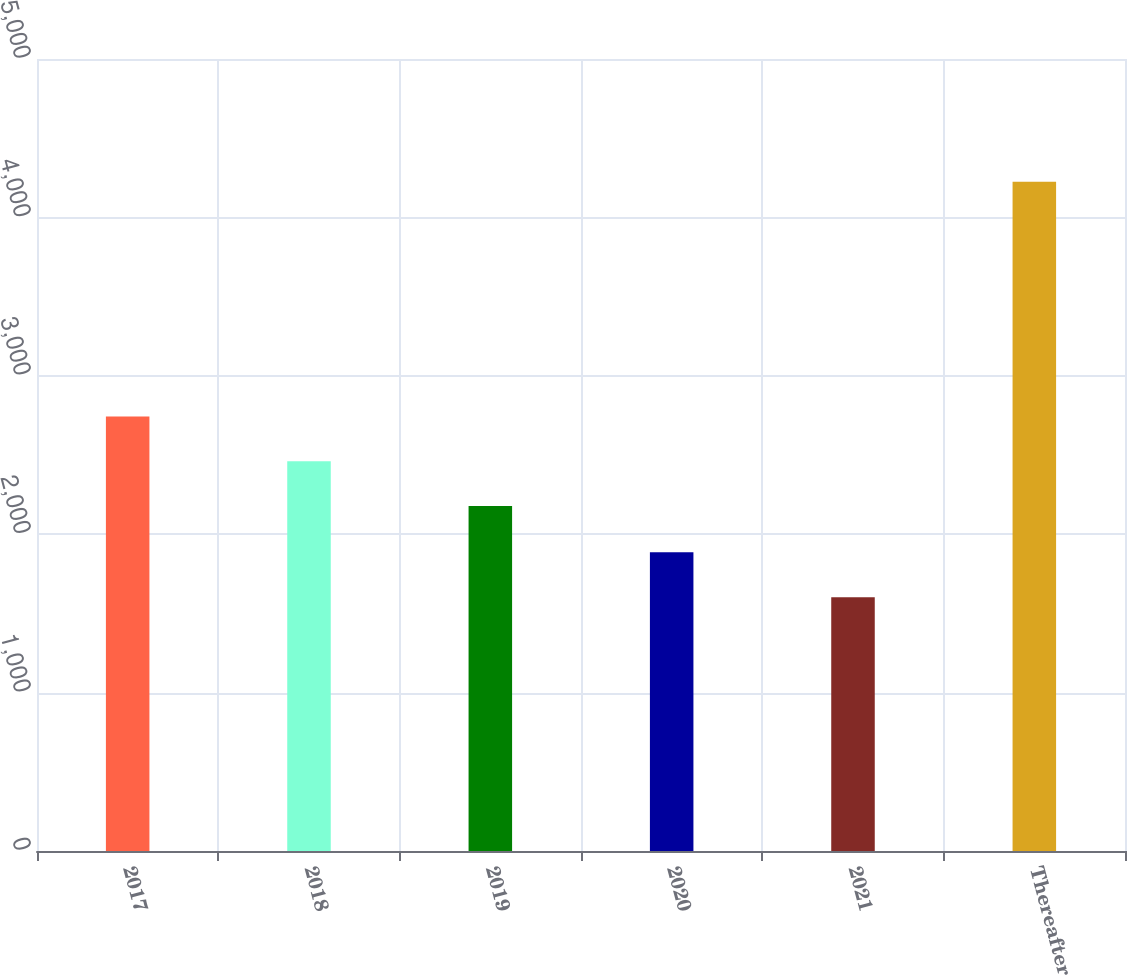Convert chart to OTSL. <chart><loc_0><loc_0><loc_500><loc_500><bar_chart><fcel>2017<fcel>2018<fcel>2019<fcel>2020<fcel>2021<fcel>Thereafter<nl><fcel>2743<fcel>2461<fcel>2178<fcel>1886<fcel>1602<fcel>4225<nl></chart> 